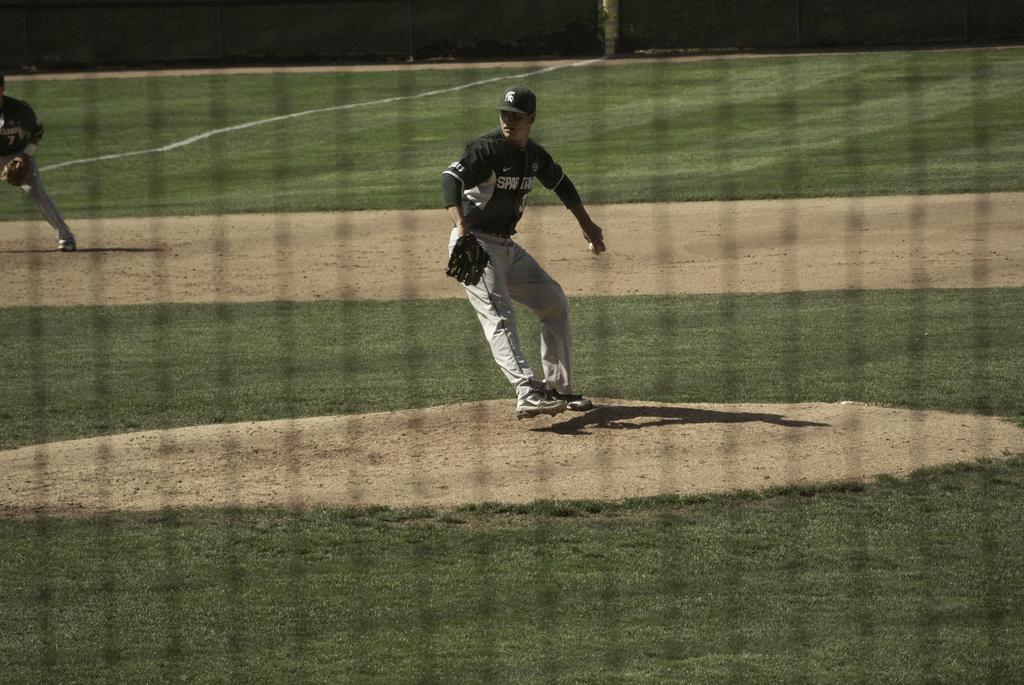What is the person in the image holding? The person is holding a ball in the image. How many people are standing in the image? There are two people standing in the image. What can be seen in the background of the image? There is grass visible in the background of the image. What type of rail can be seen in the image? There is no rail present in the image. Can you tell me the value of the cat in the image? There is no cat present in the image, so it is not possible to determine its value. 